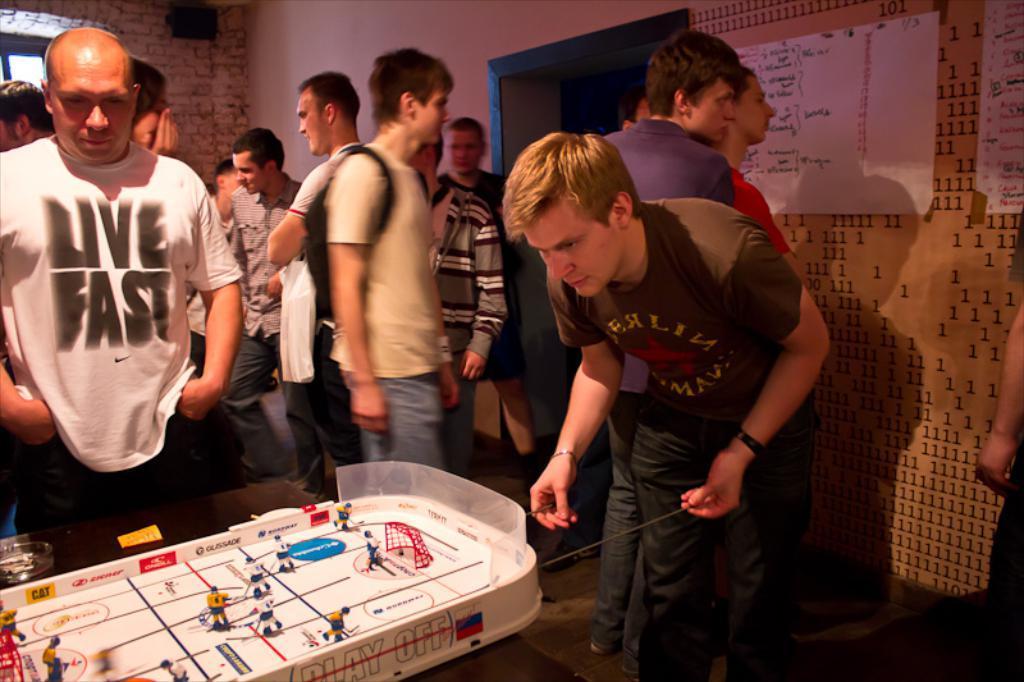Please provide a concise description of this image. In this picture we can see a group of people standing on the floor and in front of them we can see toys and a glass on a table and in the background we can see wall, posters. 